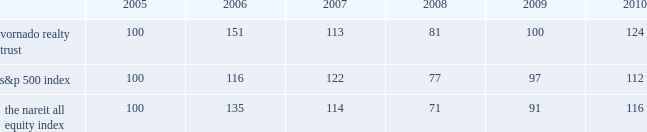Performance graph the following graph is a comparison of the five-year cumulative return of our common shares , the standard & poor 2019s 500 index ( the 201cs&p 500 index 201d ) and the national association of real estate investment trusts 2019 ( 201cnareit 201d ) all equity index ( excluding health care real estate investment trusts ) , a peer group index .
The graph assumes that $ 100 was invested on december 31 , 2005 in our common shares , the s&p 500 index and the nareit all equity index and that all dividends were reinvested without the payment of any commissions .
There can be no assurance that the performance of our shares will continue in line with the same or similar trends depicted in the graph below. .

What was the average price of the the nareit all equity index from 2005 to 2009? 
Rationale: the average share price over the 5 years is the sum of the share price divide by 5
Computations: ((((((100 + 135) + 114) + 71) + 91) + 5) / 2)
Answer: 258.0. 